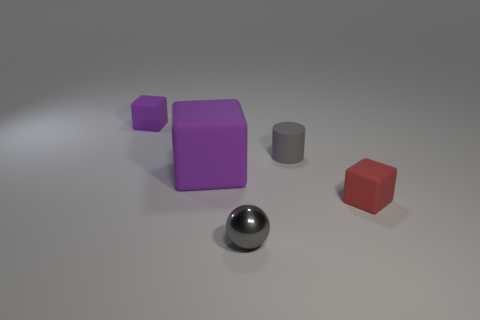Is there anything else that has the same material as the tiny sphere?
Provide a short and direct response. No. There is a small block that is left of the tiny red rubber object; what is its color?
Offer a terse response. Purple. Does the metallic sphere have the same color as the tiny matte cylinder on the right side of the large rubber object?
Ensure brevity in your answer.  Yes. Is the number of tiny blocks less than the number of small gray rubber objects?
Offer a very short reply. No. Does the cube that is behind the big purple rubber block have the same color as the big block?
Give a very brief answer. Yes. How many purple things have the same size as the shiny ball?
Provide a succinct answer. 1. Are there any small metal spheres of the same color as the tiny cylinder?
Offer a very short reply. Yes. Is the gray cylinder made of the same material as the small gray sphere?
Provide a succinct answer. No. How many big purple rubber objects have the same shape as the tiny purple rubber object?
Make the answer very short. 1. There is a large object that is the same material as the cylinder; what shape is it?
Keep it short and to the point. Cube. 